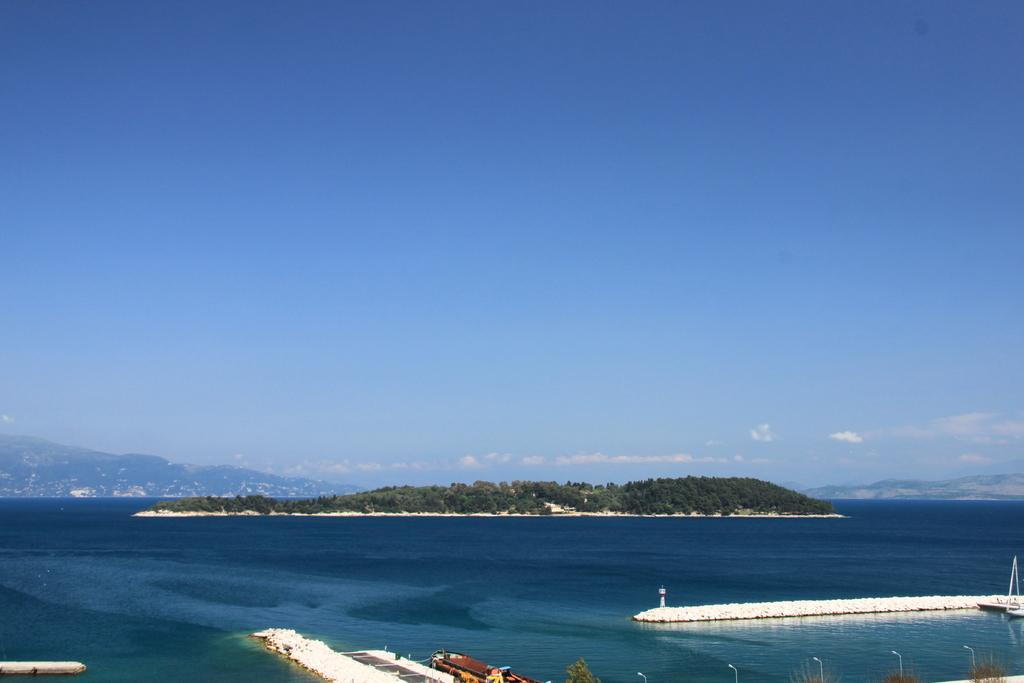What type of vehicles can be seen in the water in the image? There are boats in the water in the image. What structure can be seen in the image? There is a fence in the image. What type of structures provide light in the image? There are light poles in the image. What type of natural elements can be seen in the background of the image? There are trees, mountains, and buildings in the background of the image. What part of the natural environment is visible in the background of the image? The sky is visible in the background of the image. What might be the location of the image based on the background elements? The image may have been taken near the ocean, given the presence of water and the possibility of mountains and trees being near the coast. What type of hall can be seen in the image? There is no hall present in the image. What relation does the hydrant have with the boats in the image? There is no hydrant present in the image, so it cannot have any relation with the boats. 